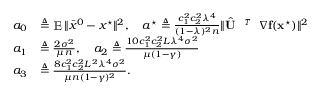<formula> <loc_0><loc_0><loc_500><loc_500>\begin{array} { r l } { a _ { 0 } } & { \triangle q \mathbb { E } \| \bar { x } ^ { 0 } - x ^ { ^ { * } } \| ^ { 2 } , \quad a ^ { ^ { * } } \triangle q \frac { c _ { 1 } ^ { 2 } c _ { 2 } ^ { 2 } \lambda ^ { 4 } } { ( 1 - \lambda ) ^ { 2 } n } \| \hat { U } ^ { T } { \nabla } f ( x ^ { ^ { * } } ) \| ^ { 2 } } \\ { a _ { 1 } } & { \triangle q \frac { 2 \sigma ^ { 2 } } { \mu n } , \quad a _ { 2 } \triangle q \frac { 1 0 c _ { 1 } ^ { 2 } c _ { 2 } ^ { 2 } L \lambda ^ { 4 } \sigma ^ { 2 } } { \mu ( 1 - \gamma ) } } \\ { a _ { 3 } } & { \triangle q \frac { 8 c _ { 1 } ^ { 2 } c _ { 2 } ^ { 2 } L ^ { 2 } \lambda ^ { 4 } \sigma ^ { 2 } } { \mu n ( 1 - \gamma ) ^ { 2 } } . } \end{array}</formula> 